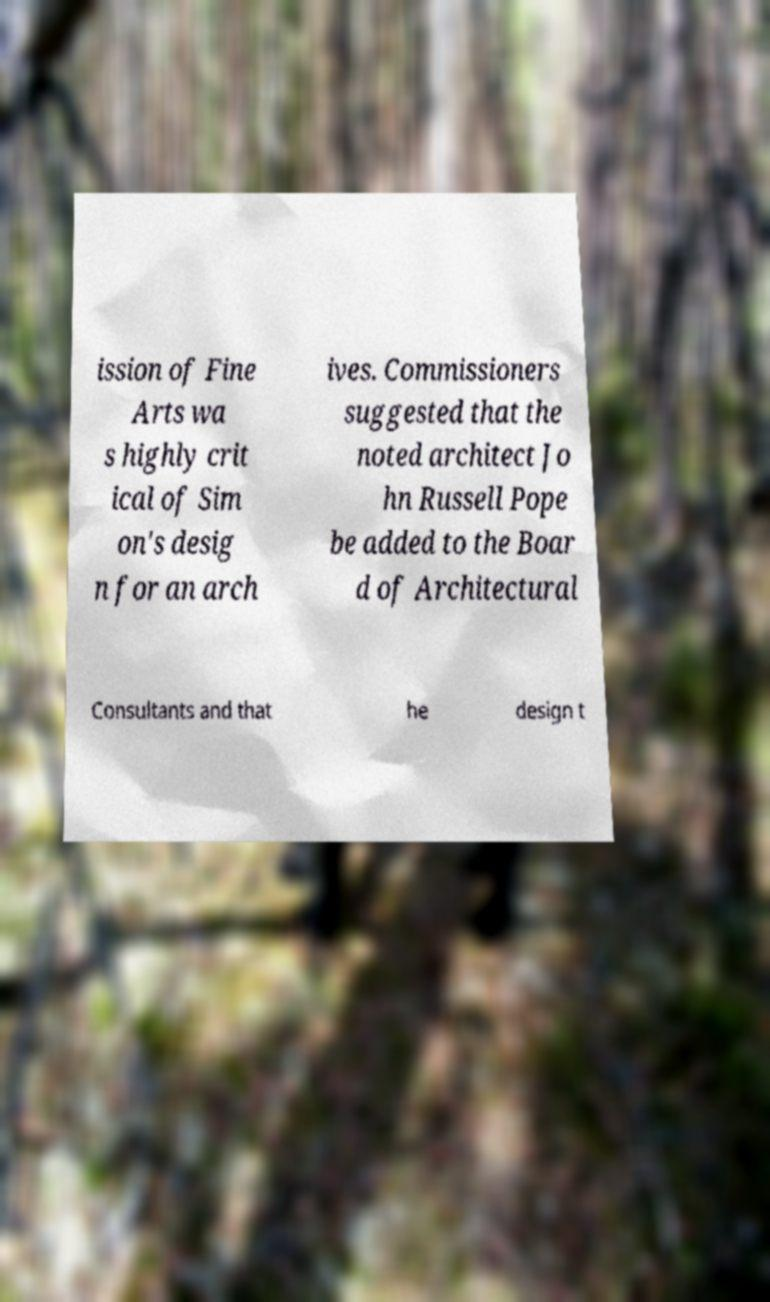Can you accurately transcribe the text from the provided image for me? ission of Fine Arts wa s highly crit ical of Sim on's desig n for an arch ives. Commissioners suggested that the noted architect Jo hn Russell Pope be added to the Boar d of Architectural Consultants and that he design t 